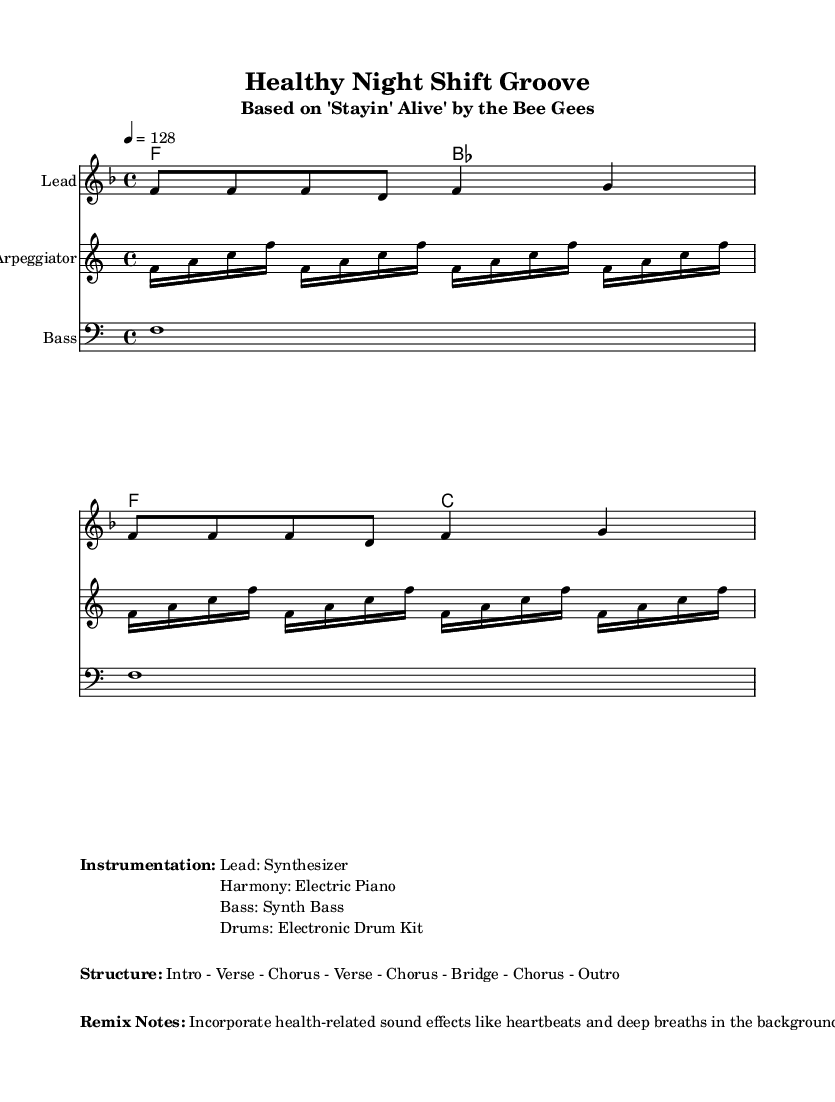What is the key signature of this music? The key signature shown in the music indicates F major, as there is one flat (B flat). This is derived from examining the global settings in the code.
Answer: F major What is the time signature of the piece? The time signature is 4/4, which can be found in the global section of the code where the time is explicitly stated. This indicates four beats per measure.
Answer: 4/4 What is the tempo marking of the piece? The tempo marking indicates a speed of 128 beats per minute, which is noted in the global section of the code. This means the music should be played at a lively, upbeat pace.
Answer: 128 How many measures are shown in the melody section? The melody section consists of 4 measures as indicated by the musical notation in the melody line. Each measure is separated by a vertical line.
Answer: 4 What is the structure of the music as noted in the markup? The music structure is detailed in the markup section, which specifies the order of sections in the piece as Intro - Verse - Chorus - Verse - Chorus - Bridge - Chorus - Outro. This shows the overall organization of the composition.
Answer: Intro - Verse - Chorus - Verse - Chorus - Bridge - Chorus - Outro What type of instrument is used for the lead part? The lead part is indicated to be played on a synthesizer, as specified in the instrumentation markup section detailing the instrumental roles.
Answer: Synthesizer What unique sound effects are included in the remix notes? The remix notes mention incorporating health-related sound effects such as heartbeats and deep breaths. This adds a thematic element related to health and wellness to the music's background.
Answer: Heartbeats and deep breaths 